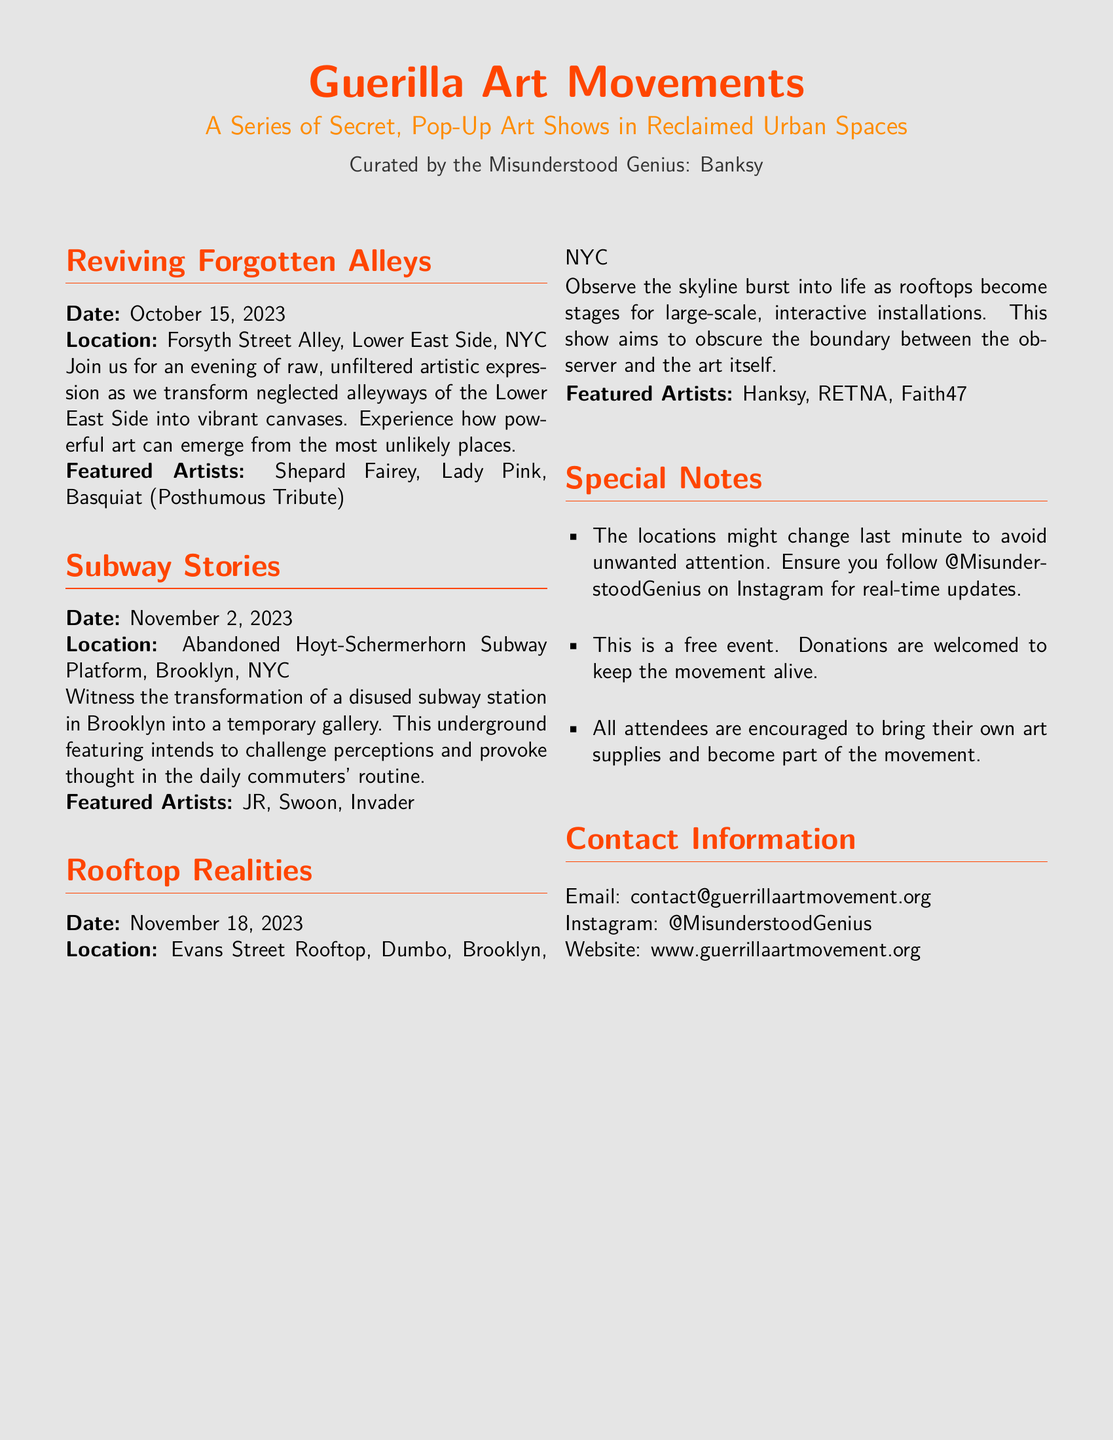What is the title of the event? The title of the event is listed at the beginning of the document as "Guerilla Art Movements".
Answer: Guerilla Art Movements Who curated the art shows? The document mentions that the shows are curated by "the Misunderstood Genius: Banksy".
Answer: Banksy What is the date of the event “Rooftop Realities”? The document provides a specific date for the "Rooftop Realities" event, which is mentioned in the section.
Answer: November 18, 2023 Where is "Subway Stories" located? The location of the "Subway Stories" event is specified in the document.
Answer: Abandoned Hoyt-Schermerhorn Subway Platform, Brooklyn, NYC Which artist is featured in "Reviving Forgotten Alleys"? One of the featured artists listed in the "Reviving Forgotten Alleys" section is mentioned.
Answer: Shepard Fairey What type of events does this Playbill advertise? The Playbill describes a series of pop-up art shows in urban spaces, implying a specific type of event.
Answer: Art Shows What should attendees bring to the events? The document encourages attendees to participate actively by bringing specific items.
Answer: Their own art supplies How can people get real-time updates about the locations? The document advises following a specific social media account for updates.
Answer: @MisunderstoodGenius on Instagram What is the nature of the artwork showcased in these events? The events aim to create immersive experiences that challenge conventional perceptions of art.
Answer: Interactive installations 